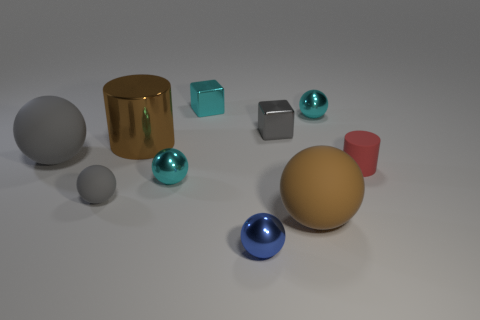Can you describe the lighting in the image? The lighting in the image appears soft and diffused, coming predominantly from above. It creates gentle shadows on the ground and highlights the metallic sheen of the gold cylinder and the high-gloss finish on some of the spheres. 